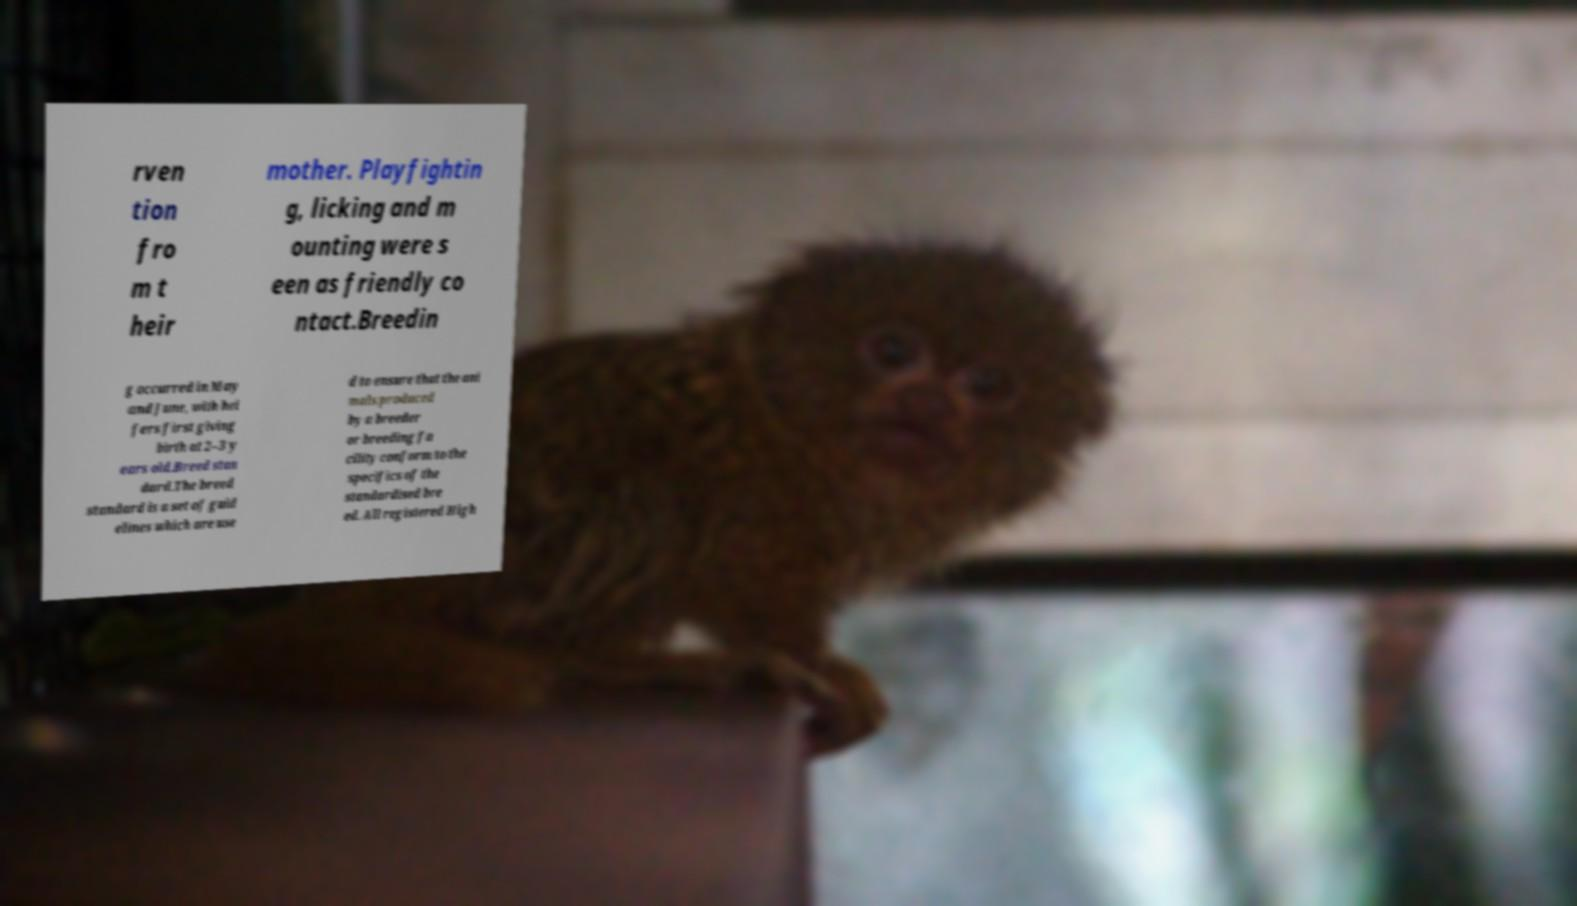I need the written content from this picture converted into text. Can you do that? rven tion fro m t heir mother. Playfightin g, licking and m ounting were s een as friendly co ntact.Breedin g occurred in May and June, with hei fers first giving birth at 2–3 y ears old.Breed stan dard.The breed standard is a set of guid elines which are use d to ensure that the ani mals produced by a breeder or breeding fa cility conform to the specifics of the standardised bre ed. All registered High 